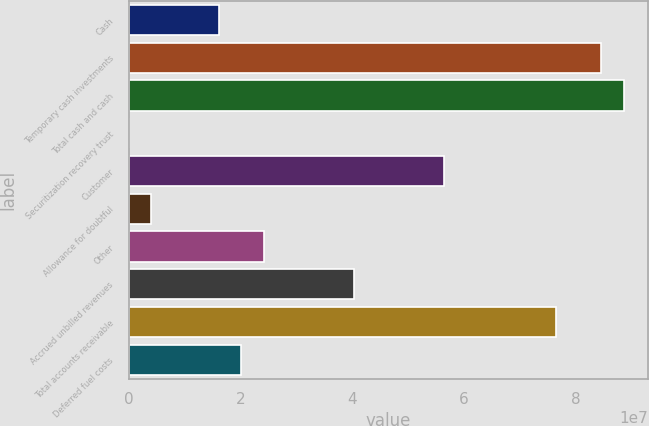<chart> <loc_0><loc_0><loc_500><loc_500><bar_chart><fcel>Cash<fcel>Temporary cash investments<fcel>Total cash and cash<fcel>Securitization recovery trust<fcel>Customer<fcel>Allowance for doubtful<fcel>Other<fcel>Accrued unbilled revenues<fcel>Total accounts receivable<fcel>Deferred fuel costs<nl><fcel>1.61102e+07<fcel>8.45228e+07<fcel>8.8547e+07<fcel>13098<fcel>5.63529e+07<fcel>4.03737e+06<fcel>2.41587e+07<fcel>4.02558e+07<fcel>7.64742e+07<fcel>2.01344e+07<nl></chart> 